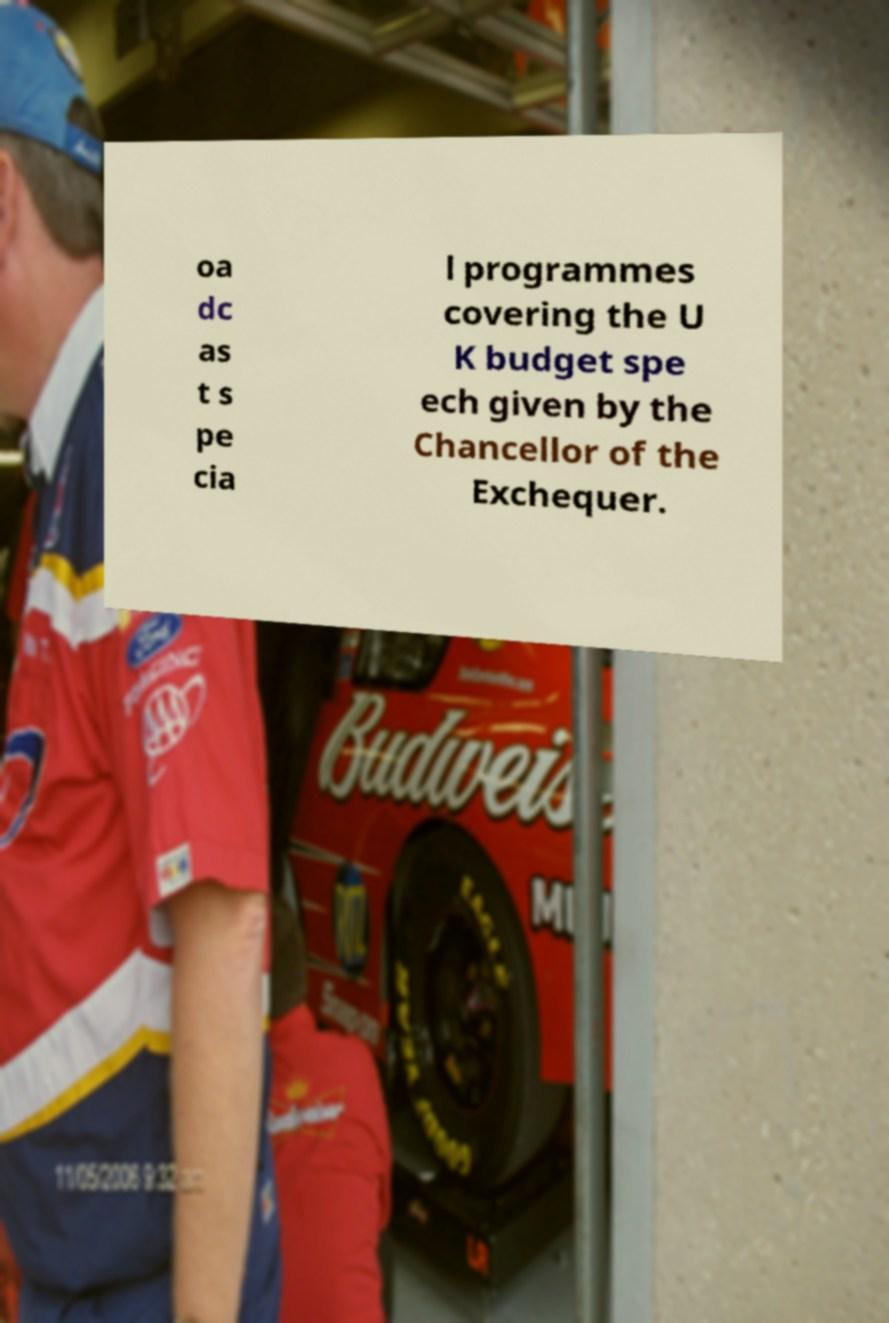Could you extract and type out the text from this image? oa dc as t s pe cia l programmes covering the U K budget spe ech given by the Chancellor of the Exchequer. 